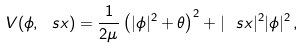<formula> <loc_0><loc_0><loc_500><loc_500>V ( \phi , \ s x ) = \frac { 1 } { 2 \mu } \left ( | \phi | ^ { 2 } + \theta \right ) ^ { 2 } + | \ s x | ^ { 2 } | \phi | ^ { 2 } \, ,</formula> 